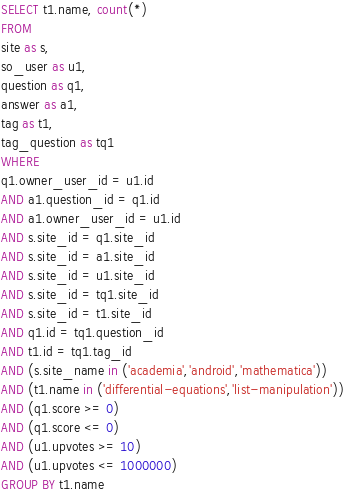<code> <loc_0><loc_0><loc_500><loc_500><_SQL_>SELECT t1.name, count(*)
FROM
site as s,
so_user as u1,
question as q1,
answer as a1,
tag as t1,
tag_question as tq1
WHERE
q1.owner_user_id = u1.id
AND a1.question_id = q1.id
AND a1.owner_user_id = u1.id
AND s.site_id = q1.site_id
AND s.site_id = a1.site_id
AND s.site_id = u1.site_id
AND s.site_id = tq1.site_id
AND s.site_id = t1.site_id
AND q1.id = tq1.question_id
AND t1.id = tq1.tag_id
AND (s.site_name in ('academia','android','mathematica'))
AND (t1.name in ('differential-equations','list-manipulation'))
AND (q1.score >= 0)
AND (q1.score <= 0)
AND (u1.upvotes >= 10)
AND (u1.upvotes <= 1000000)
GROUP BY t1.name</code> 